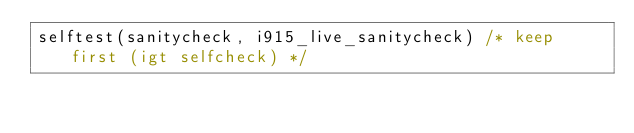Convert code to text. <code><loc_0><loc_0><loc_500><loc_500><_C_>selftest(sanitycheck, i915_live_sanitycheck) /* keep first (igt selfcheck) */</code> 